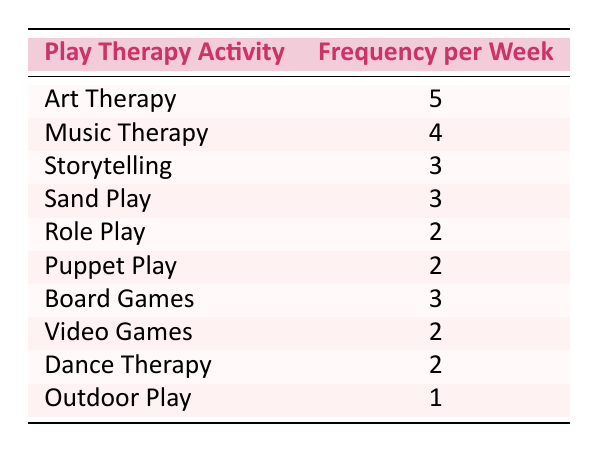What is the most frequently used play therapy activity? By examining the "Frequency per Week" column, we see that "Art Therapy" has the highest frequency at 5 times per week.
Answer: Art Therapy How many times per week is "Music Therapy" used? From the table, "Music Therapy" is listed with a frequency of 4 times per week.
Answer: 4 Which play therapy activities have a frequency of 2 per week? Looking through the table, the activities listed with a frequency of 2 are "Role Play," "Puppet Play," "Video Games," and "Dance Therapy."
Answer: Role Play, Puppet Play, Video Games, Dance Therapy What is the total frequency of play therapy activities that are used 3 times or more per week? The activities with 3 or more frequencies are "Art Therapy" (5) + "Music Therapy" (4) + "Storytelling" (3) + "Sand Play" (3) + "Board Games" (3), totaling 18. Thus, the calculation is 5 + 4 + 3 + 3 + 3 = 18.
Answer: 18 Is "Outdoor Play" used more than 2 times per week? The table indicates that "Outdoor Play" is used only 1 time per week, which is less than 2 times. Therefore, the answer is no.
Answer: No Which play therapy activity has the lowest frequency and how often is it used? The lowest frequency activity in the table is "Outdoor Play," used only once per week.
Answer: Outdoor Play, 1 time If we consider the average frequency of all listed play therapy activities, what would it be? We calculate the average by first summing all frequencies: (5 + 4 + 3 + 3 + 2 + 2 + 3 + 2 + 2 + 1) = 27. There are 10 activities, so the average is 27/10 = 2.7.
Answer: 2.7 How many play therapy activities are used 3 times or less per week? The activities used 3 times or less per week are "Storytelling," "Sand Play," "Role Play," "Puppet Play," "Video Games," "Dance Therapy," and "Outdoor Play." In total, this is 7 activities.
Answer: 7 Which type of play therapy is used more often, "Sand Play" or "Board Games"? The table shows that "Sand Play" is used 3 times per week, while "Board Games" is also used 3 times per week. Therefore, they are used equally often.
Answer: They are used equally often 